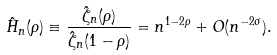Convert formula to latex. <formula><loc_0><loc_0><loc_500><loc_500>\hat { H } _ { n } ( \rho ) \equiv \frac { \hat { \zeta } _ { n } ( \rho ) } { \hat { \zeta } _ { n } ( 1 - \rho ) } = n ^ { 1 - 2 \rho } + O ( n ^ { - 2 \sigma } ) .</formula> 